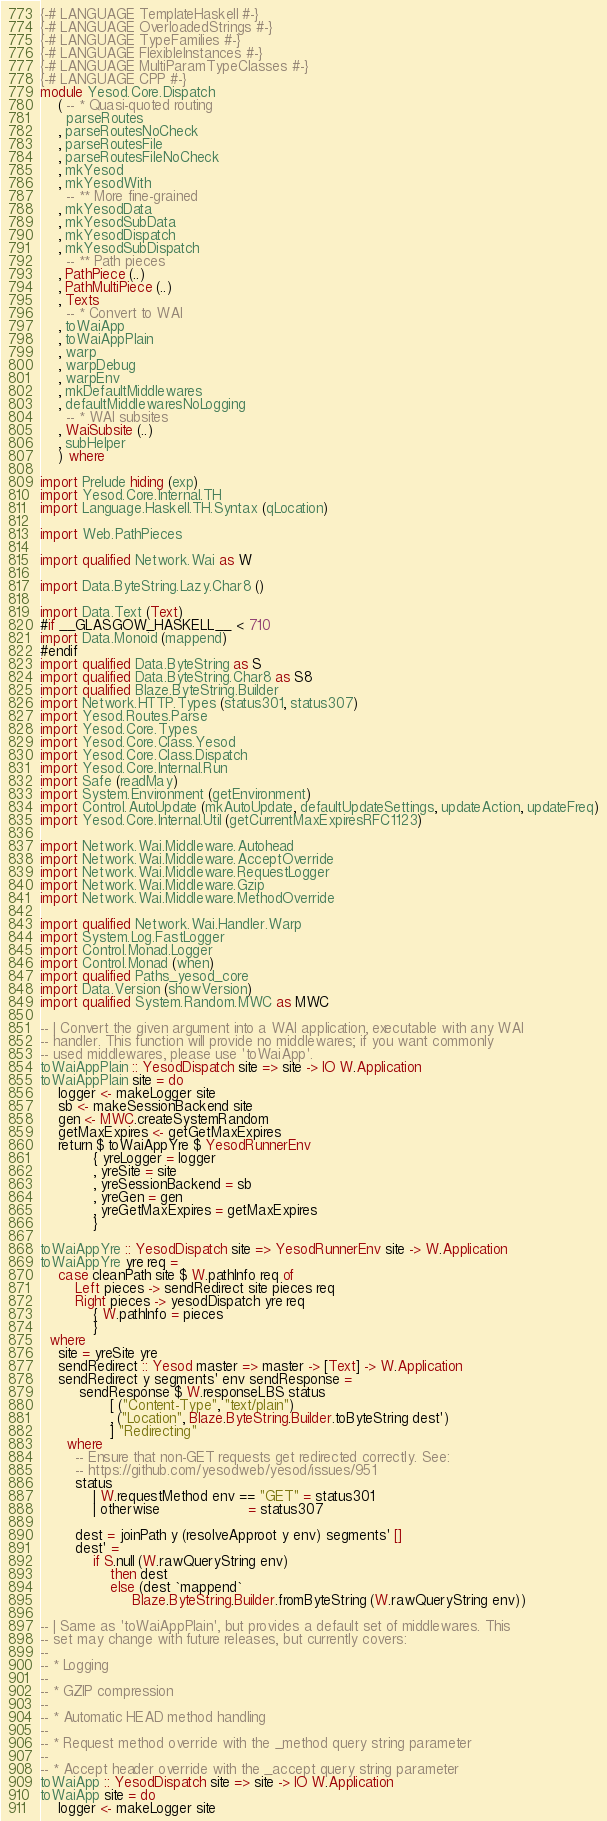<code> <loc_0><loc_0><loc_500><loc_500><_Haskell_>{-# LANGUAGE TemplateHaskell #-}
{-# LANGUAGE OverloadedStrings #-}
{-# LANGUAGE TypeFamilies #-}
{-# LANGUAGE FlexibleInstances #-}
{-# LANGUAGE MultiParamTypeClasses #-}
{-# LANGUAGE CPP #-}
module Yesod.Core.Dispatch
    ( -- * Quasi-quoted routing
      parseRoutes
    , parseRoutesNoCheck
    , parseRoutesFile
    , parseRoutesFileNoCheck
    , mkYesod
    , mkYesodWith
      -- ** More fine-grained
    , mkYesodData
    , mkYesodSubData
    , mkYesodDispatch
    , mkYesodSubDispatch
      -- ** Path pieces
    , PathPiece (..)
    , PathMultiPiece (..)
    , Texts
      -- * Convert to WAI
    , toWaiApp
    , toWaiAppPlain
    , warp
    , warpDebug
    , warpEnv
    , mkDefaultMiddlewares
    , defaultMiddlewaresNoLogging
      -- * WAI subsites
    , WaiSubsite (..)
    , subHelper
    ) where

import Prelude hiding (exp)
import Yesod.Core.Internal.TH
import Language.Haskell.TH.Syntax (qLocation)

import Web.PathPieces

import qualified Network.Wai as W

import Data.ByteString.Lazy.Char8 ()

import Data.Text (Text)
#if __GLASGOW_HASKELL__ < 710
import Data.Monoid (mappend)
#endif
import qualified Data.ByteString as S
import qualified Data.ByteString.Char8 as S8
import qualified Blaze.ByteString.Builder
import Network.HTTP.Types (status301, status307)
import Yesod.Routes.Parse
import Yesod.Core.Types
import Yesod.Core.Class.Yesod
import Yesod.Core.Class.Dispatch
import Yesod.Core.Internal.Run
import Safe (readMay)
import System.Environment (getEnvironment)
import Control.AutoUpdate (mkAutoUpdate, defaultUpdateSettings, updateAction, updateFreq)
import Yesod.Core.Internal.Util (getCurrentMaxExpiresRFC1123)

import Network.Wai.Middleware.Autohead
import Network.Wai.Middleware.AcceptOverride
import Network.Wai.Middleware.RequestLogger
import Network.Wai.Middleware.Gzip
import Network.Wai.Middleware.MethodOverride

import qualified Network.Wai.Handler.Warp
import System.Log.FastLogger
import Control.Monad.Logger
import Control.Monad (when)
import qualified Paths_yesod_core
import Data.Version (showVersion)
import qualified System.Random.MWC as MWC

-- | Convert the given argument into a WAI application, executable with any WAI
-- handler. This function will provide no middlewares; if you want commonly
-- used middlewares, please use 'toWaiApp'.
toWaiAppPlain :: YesodDispatch site => site -> IO W.Application
toWaiAppPlain site = do
    logger <- makeLogger site
    sb <- makeSessionBackend site
    gen <- MWC.createSystemRandom
    getMaxExpires <- getGetMaxExpires
    return $ toWaiAppYre $ YesodRunnerEnv
            { yreLogger = logger
            , yreSite = site
            , yreSessionBackend = sb
            , yreGen = gen
            , yreGetMaxExpires = getMaxExpires
            }

toWaiAppYre :: YesodDispatch site => YesodRunnerEnv site -> W.Application
toWaiAppYre yre req =
    case cleanPath site $ W.pathInfo req of
        Left pieces -> sendRedirect site pieces req
        Right pieces -> yesodDispatch yre req
            { W.pathInfo = pieces
            }
  where
    site = yreSite yre
    sendRedirect :: Yesod master => master -> [Text] -> W.Application
    sendRedirect y segments' env sendResponse =
         sendResponse $ W.responseLBS status
                [ ("Content-Type", "text/plain")
                , ("Location", Blaze.ByteString.Builder.toByteString dest')
                ] "Redirecting"
      where
        -- Ensure that non-GET requests get redirected correctly. See:
        -- https://github.com/yesodweb/yesod/issues/951
        status
            | W.requestMethod env == "GET" = status301
            | otherwise                    = status307

        dest = joinPath y (resolveApproot y env) segments' []
        dest' =
            if S.null (W.rawQueryString env)
                then dest
                else (dest `mappend`
                     Blaze.ByteString.Builder.fromByteString (W.rawQueryString env))

-- | Same as 'toWaiAppPlain', but provides a default set of middlewares. This
-- set may change with future releases, but currently covers:
--
-- * Logging
--
-- * GZIP compression
--
-- * Automatic HEAD method handling
--
-- * Request method override with the _method query string parameter
--
-- * Accept header override with the _accept query string parameter
toWaiApp :: YesodDispatch site => site -> IO W.Application
toWaiApp site = do
    logger <- makeLogger site</code> 